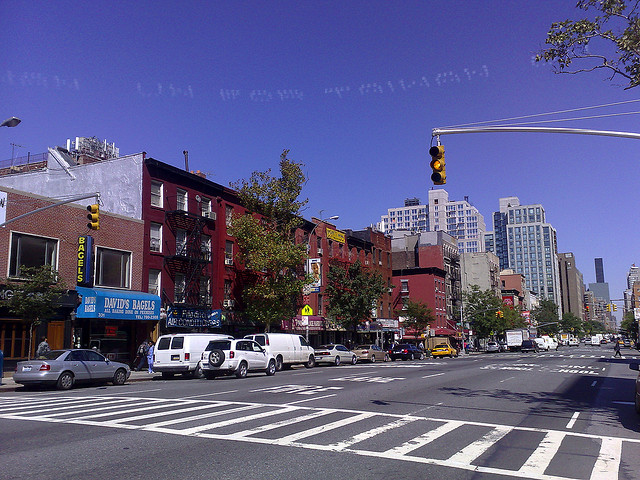Identify and read out the text in this image. BACELS DAVIDS BAGELS 